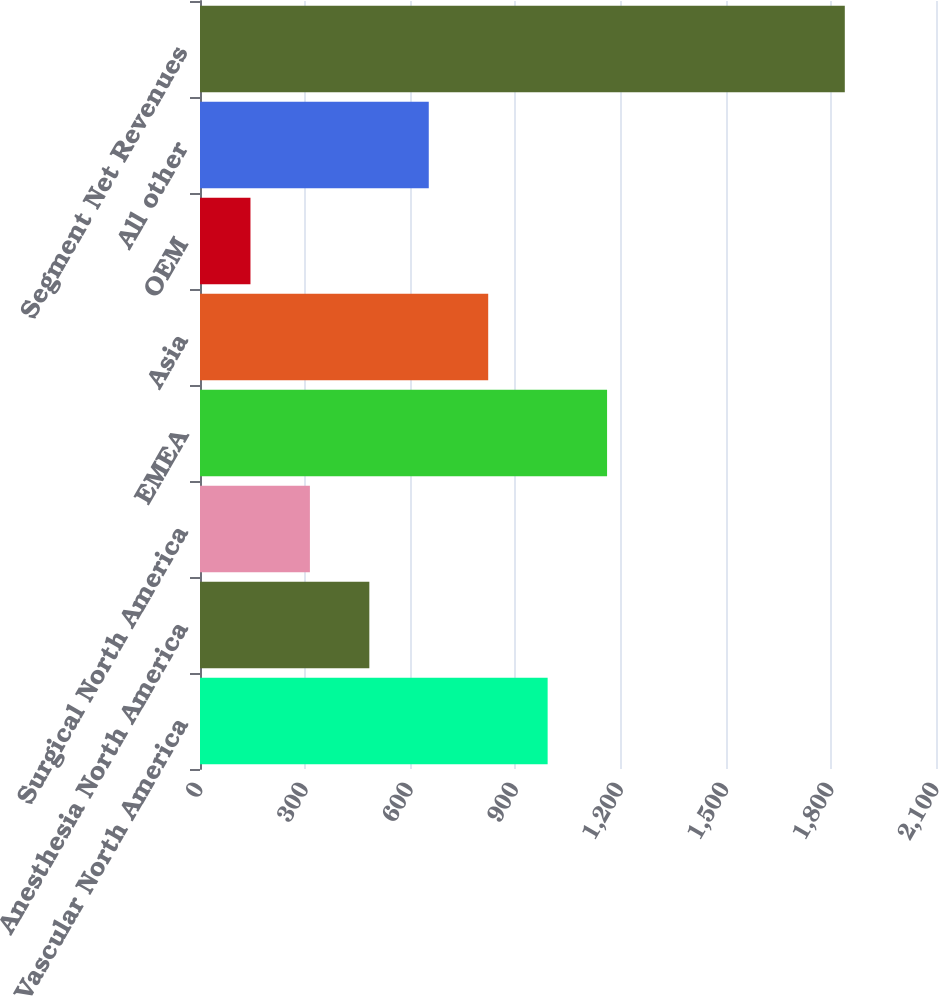<chart> <loc_0><loc_0><loc_500><loc_500><bar_chart><fcel>Vascular North America<fcel>Anesthesia North America<fcel>Surgical North America<fcel>EMEA<fcel>Asia<fcel>OEM<fcel>All other<fcel>Segment Net Revenues<nl><fcel>991.9<fcel>483.16<fcel>313.58<fcel>1161.48<fcel>822.32<fcel>144<fcel>652.74<fcel>1839.8<nl></chart> 